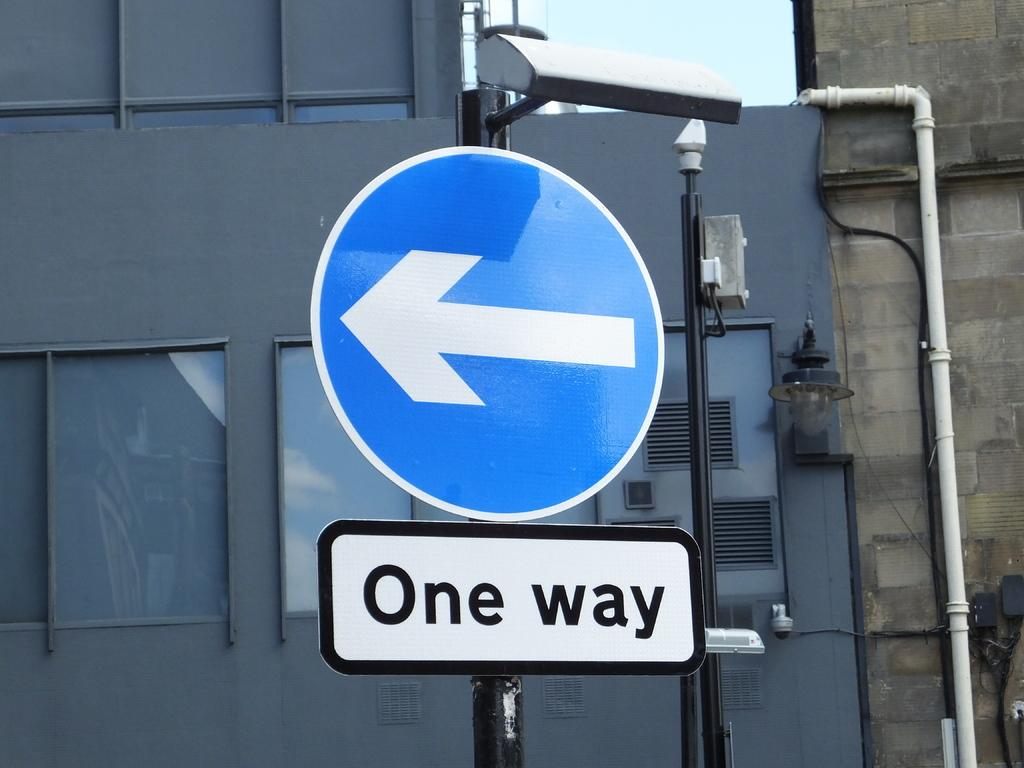<image>
Summarize the visual content of the image. A blue arrow sign is above a smaller white sign that says One Way. 